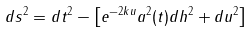<formula> <loc_0><loc_0><loc_500><loc_500>d s ^ { 2 } = d t ^ { 2 } - \left [ e ^ { - 2 k u } a ^ { 2 } ( t ) d { h } ^ { 2 } + d u ^ { 2 } \right ]</formula> 